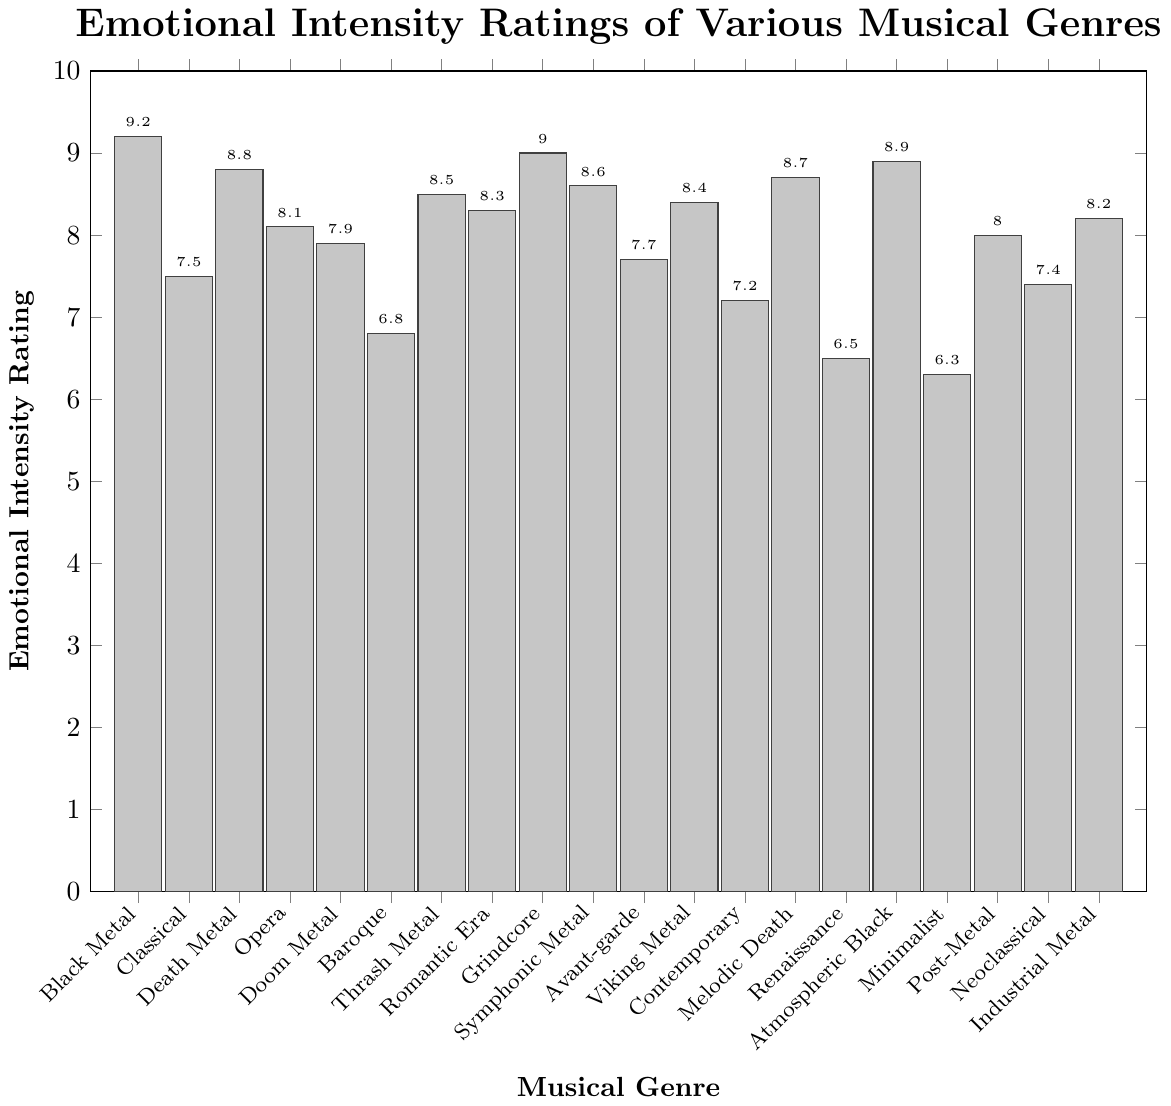Which genre has the highest emotional intensity rating? By visually inspecting the height of the bars, the highest emotional intensity rating is represented by the tallest bar. The tallest bar corresponds to "Black Metal."
Answer: Black Metal What is the difference in emotional intensity rating between Black Metal and Minimalist Classical? Subtract the emotional intensity rating of Minimalist Classical from that of Black Metal: 9.2 (Black Metal) - 6.3 (Minimalist Classical) = 2.9
Answer: 2.9 How many genres have an emotional intensity rating higher than 8.0? Count all the genres with bars higher than the 8.0 mark on the y-axis. The genres are: Black Metal, Death Metal, Thrash Metal, Grindcore, Symphonic Metal, Romantic Era Classical, Melodic Death Metal, Atmospheric Black Metal, and Industrial Metal.
Answer: 9 Which has a higher emotional intensity rating, Opera or Industrial Metal, and by how much? Compare the bar heights of Opera (8.1) and Industrial Metal (8.2). Subtract the smaller value from the larger: 8.2 (Industrial Metal) - 8.1 (Opera) = 0.1
Answer: Industrial Metal by 0.1 Which classical music genre has the lowest emotional intensity rating? Compare the bars for all classical music genres and find the shortest bar. The shortest bar corresponds to Minimalist Classical.
Answer: Minimalist Classical What is the average emotional intensity rating for metal genres? Sum up the ratings for all metal genres: (9.2 + 8.8 + 7.9 + 8.5 + 9.0 + 8.6 + 8.4 + 8.7 + 8.9 + 8.0 + 8.2) = 94.2. Divide by the number of metal genres (11): 94.2 / 11 ≈ 8.56
Answer: 8.56 Are there more classical music genres or metal genres presented in the plot? Count the number of classical music genres (6): Classical, Baroque, Romantic Era Classical, Avant-garde Classical, Contemporary Classical, Minimalist Classical. Count the metal genres (11): Black Metal, Death Metal, Doom Metal, Thrash Metal, Grindcore, Symphonic Metal, Viking Metal, Melodic Death Metal, Atmospheric Black Metal, Post-Metal, Industrial Metal.
Answer: More metal genres How much higher is the emotional intensity rating of Atmospheric Black Metal compared to Baroque? Subtract the emotional intensity rating of Baroque from that of Atmospheric Black Metal: 8.9 (Atmospheric Black Metal) - 6.8 (Baroque) = 2.1
Answer: 2.1 Which genre's rating is closest to the average rating of all genres? Calculate the average rating by summing up all ratings and dividing by the number of genres: (9.2 + 7.5 + 8.8 + 8.1 + 7.9 + 6.8 + 8.5 + 8.3 + 9.0 + 8.6 + 7.7 + 8.4 + 7.2 + 8.7 + 6.5 + 8.9 + 6.3 + 8.0 + 7.4 + 8.2) = 166.8. Divide by 20: 166.8 / 20 = 8.34. The closest genres are Romantic Era Classical (8.3) and Industrial Metal (8.2).
Answer: Romantic Era Classical and Industrial Metal What is the range of the emotional intensity ratings in the plot? The range is calculated by subtracting the smallest rating from the largest rating: 9.2 (Black Metal) - 6.3 (Minimalist Classical) = 2.9.
Answer: 2.9 